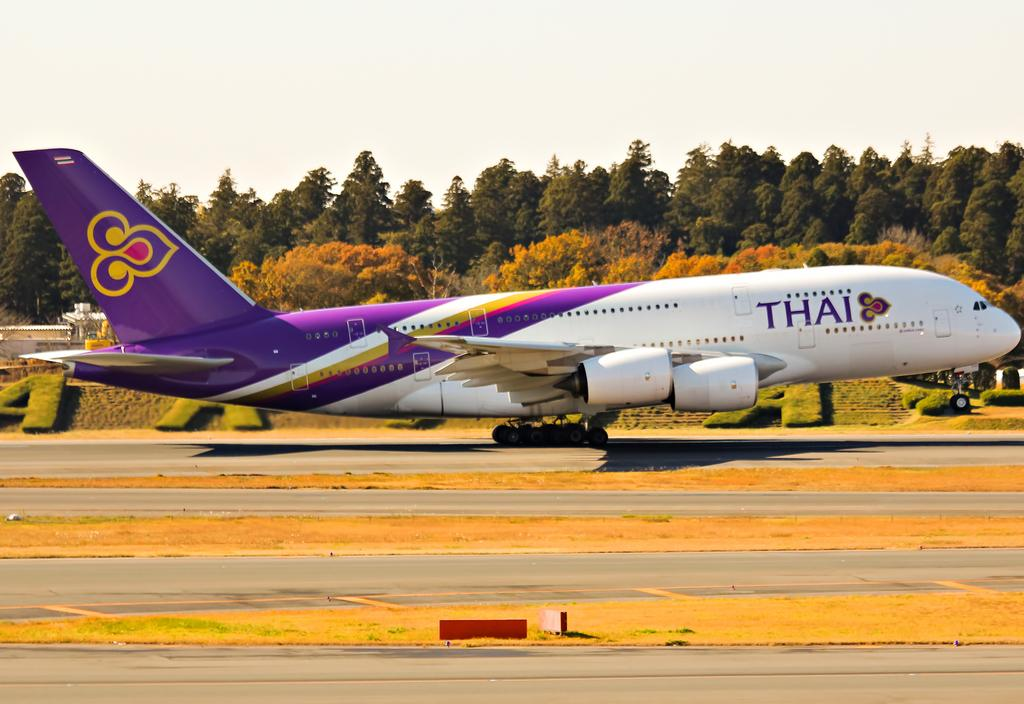<image>
Describe the image concisely. A purple and white airplane has the word Thai on the front. 